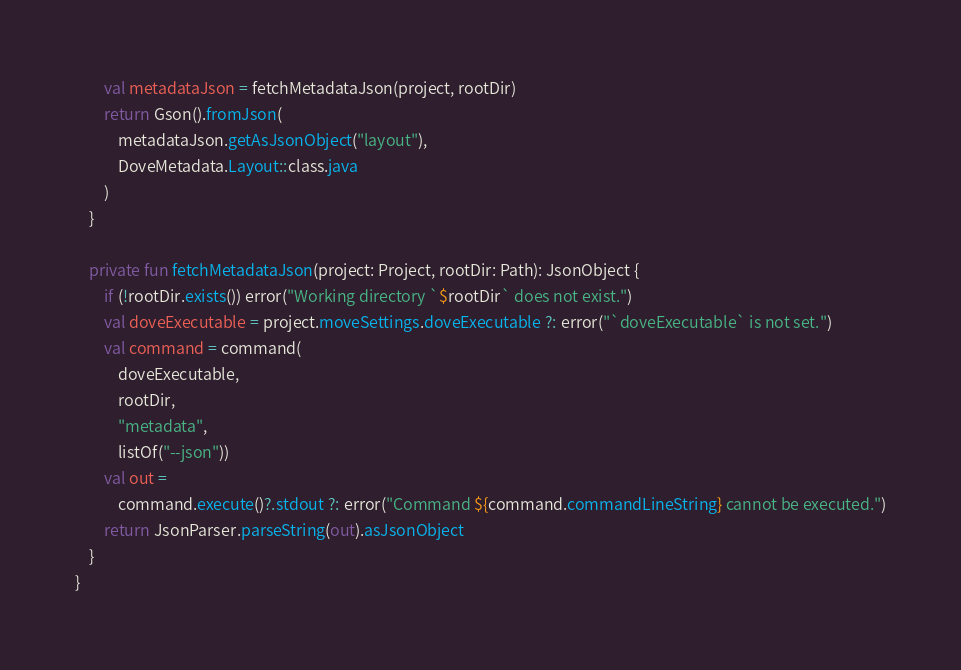<code> <loc_0><loc_0><loc_500><loc_500><_Kotlin_>        val metadataJson = fetchMetadataJson(project, rootDir)
        return Gson().fromJson(
            metadataJson.getAsJsonObject("layout"),
            DoveMetadata.Layout::class.java
        )
    }

    private fun fetchMetadataJson(project: Project, rootDir: Path): JsonObject {
        if (!rootDir.exists()) error("Working directory `$rootDir` does not exist.")
        val doveExecutable = project.moveSettings.doveExecutable ?: error("`doveExecutable` is not set.")
        val command = command(
            doveExecutable,
            rootDir,
            "metadata",
            listOf("--json"))
        val out =
            command.execute()?.stdout ?: error("Command ${command.commandLineString} cannot be executed.")
        return JsonParser.parseString(out).asJsonObject
    }
}
</code> 